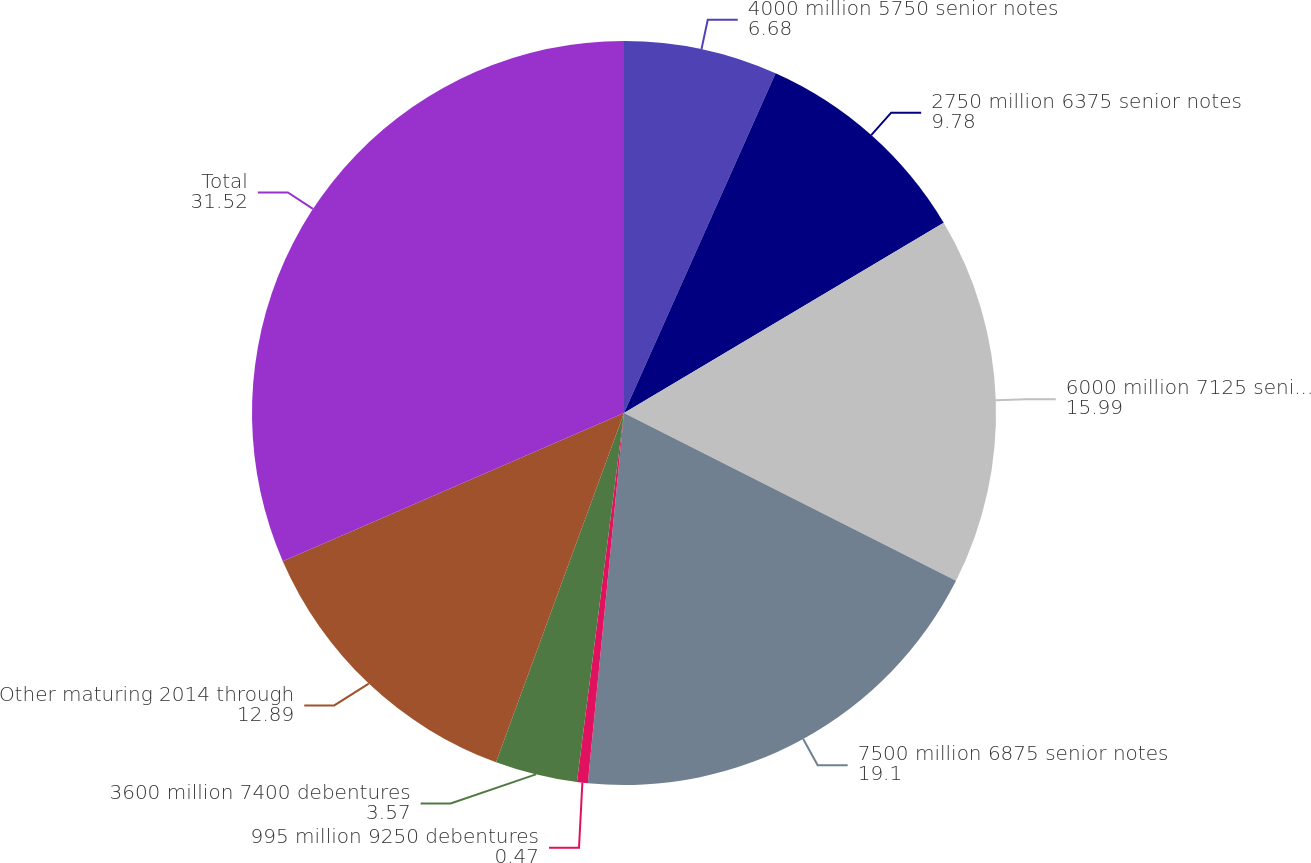Convert chart. <chart><loc_0><loc_0><loc_500><loc_500><pie_chart><fcel>4000 million 5750 senior notes<fcel>2750 million 6375 senior notes<fcel>6000 million 7125 senior notes<fcel>7500 million 6875 senior notes<fcel>995 million 9250 debentures<fcel>3600 million 7400 debentures<fcel>Other maturing 2014 through<fcel>Total<nl><fcel>6.68%<fcel>9.78%<fcel>15.99%<fcel>19.1%<fcel>0.47%<fcel>3.57%<fcel>12.89%<fcel>31.52%<nl></chart> 